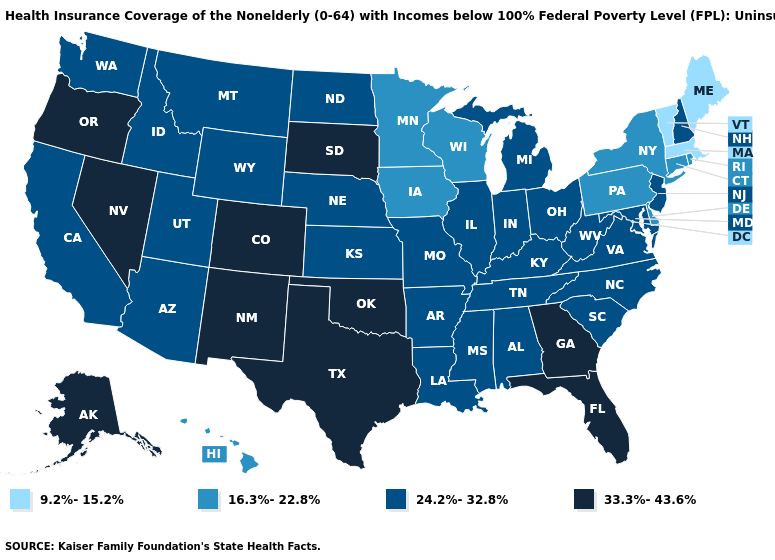Does Arizona have the highest value in the USA?
Quick response, please. No. What is the lowest value in the USA?
Answer briefly. 9.2%-15.2%. Among the states that border West Virginia , which have the highest value?
Short answer required. Kentucky, Maryland, Ohio, Virginia. Does the first symbol in the legend represent the smallest category?
Give a very brief answer. Yes. Which states have the lowest value in the USA?
Answer briefly. Maine, Massachusetts, Vermont. Name the states that have a value in the range 24.2%-32.8%?
Write a very short answer. Alabama, Arizona, Arkansas, California, Idaho, Illinois, Indiana, Kansas, Kentucky, Louisiana, Maryland, Michigan, Mississippi, Missouri, Montana, Nebraska, New Hampshire, New Jersey, North Carolina, North Dakota, Ohio, South Carolina, Tennessee, Utah, Virginia, Washington, West Virginia, Wyoming. Which states hav the highest value in the Northeast?
Short answer required. New Hampshire, New Jersey. Does Nevada have the highest value in the West?
Short answer required. Yes. Among the states that border Idaho , which have the lowest value?
Answer briefly. Montana, Utah, Washington, Wyoming. Name the states that have a value in the range 24.2%-32.8%?
Keep it brief. Alabama, Arizona, Arkansas, California, Idaho, Illinois, Indiana, Kansas, Kentucky, Louisiana, Maryland, Michigan, Mississippi, Missouri, Montana, Nebraska, New Hampshire, New Jersey, North Carolina, North Dakota, Ohio, South Carolina, Tennessee, Utah, Virginia, Washington, West Virginia, Wyoming. Name the states that have a value in the range 16.3%-22.8%?
Short answer required. Connecticut, Delaware, Hawaii, Iowa, Minnesota, New York, Pennsylvania, Rhode Island, Wisconsin. What is the lowest value in the USA?
Answer briefly. 9.2%-15.2%. What is the value of New Mexico?
Write a very short answer. 33.3%-43.6%. What is the value of North Carolina?
Quick response, please. 24.2%-32.8%. What is the value of Alaska?
Give a very brief answer. 33.3%-43.6%. 